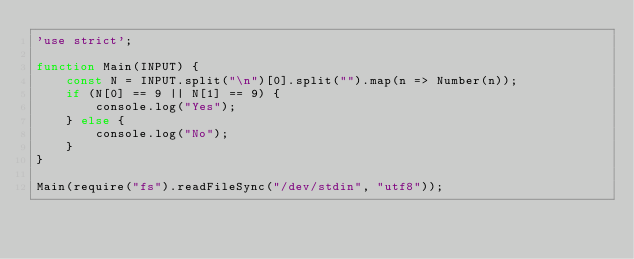Convert code to text. <code><loc_0><loc_0><loc_500><loc_500><_JavaScript_>'use strict';

function Main(INPUT) {
    const N = INPUT.split("\n")[0].split("").map(n => Number(n));
    if (N[0] == 9 || N[1] == 9) {
        console.log("Yes");
    } else {
        console.log("No");
    }
}

Main(require("fs").readFileSync("/dev/stdin", "utf8"));
</code> 